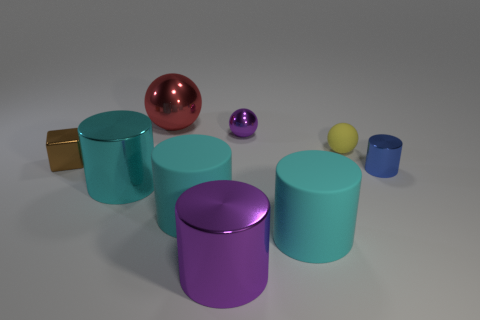Subtract all cyan cylinders. How many were subtracted if there are1cyan cylinders left? 2 Subtract all purple cubes. How many cyan cylinders are left? 3 Subtract 1 balls. How many balls are left? 2 Subtract all cyan matte cylinders. How many cylinders are left? 3 Subtract all purple cylinders. How many cylinders are left? 4 Subtract all green cylinders. Subtract all gray spheres. How many cylinders are left? 5 Add 1 blue spheres. How many objects exist? 10 Subtract all cubes. How many objects are left? 8 Subtract all small purple things. Subtract all large gray shiny cubes. How many objects are left? 8 Add 4 blue objects. How many blue objects are left? 5 